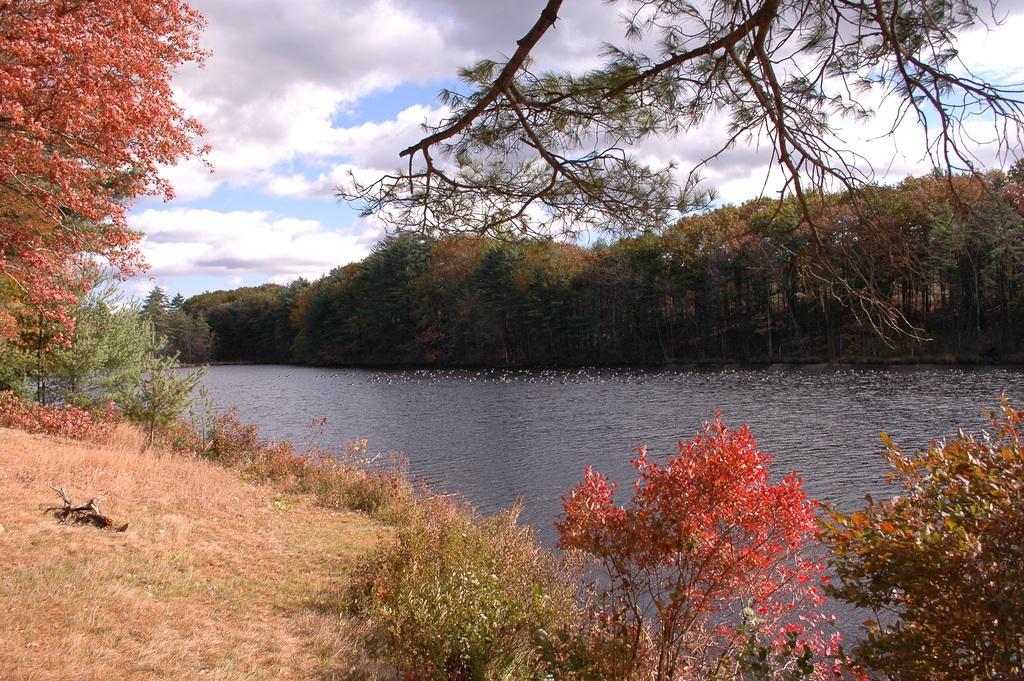Can you describe this image briefly? In the center of the image we can see water. In the background, we can see a group of trees and the cloudy sky. 